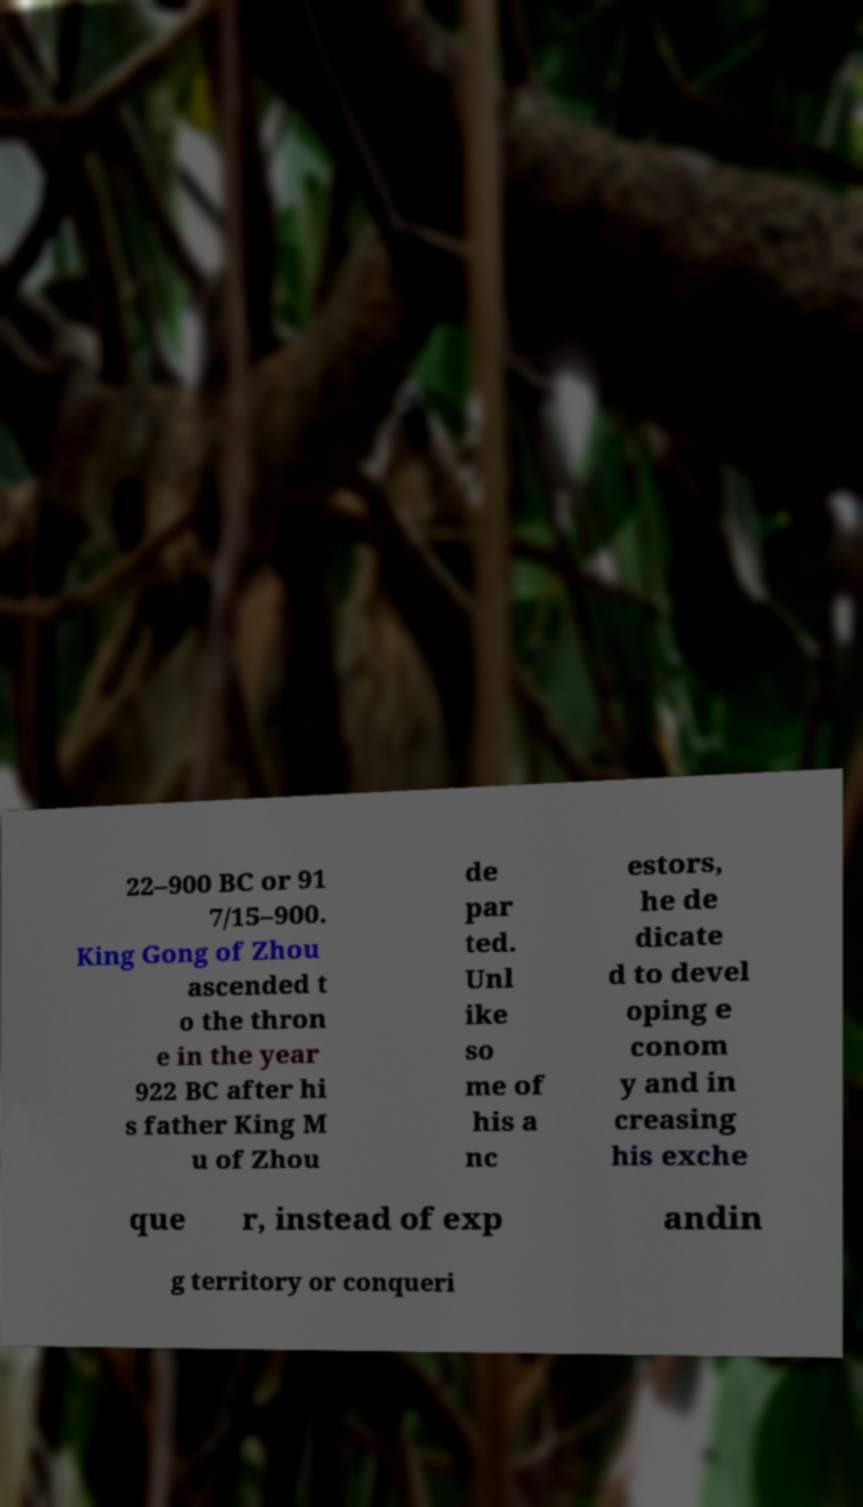Can you accurately transcribe the text from the provided image for me? 22–900 BC or 91 7/15–900. King Gong of Zhou ascended t o the thron e in the year 922 BC after hi s father King M u of Zhou de par ted. Unl ike so me of his a nc estors, he de dicate d to devel oping e conom y and in creasing his exche que r, instead of exp andin g territory or conqueri 